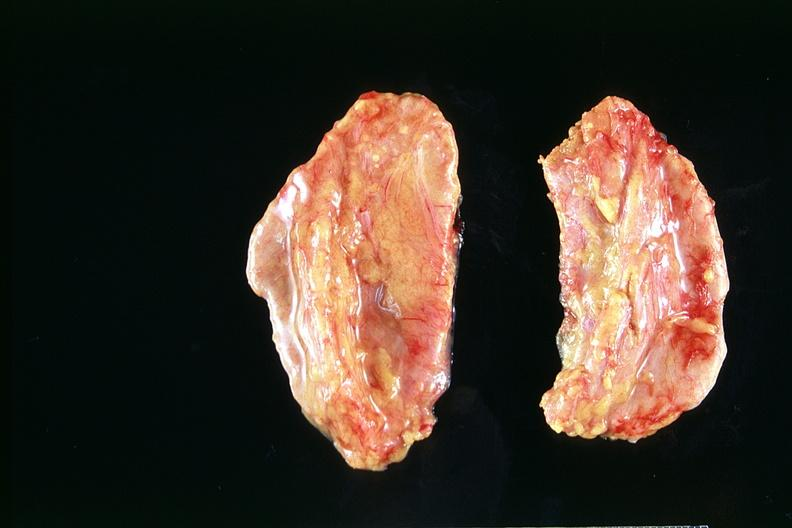where does this belong to?
Answer the question using a single word or phrase. Endocrine system 